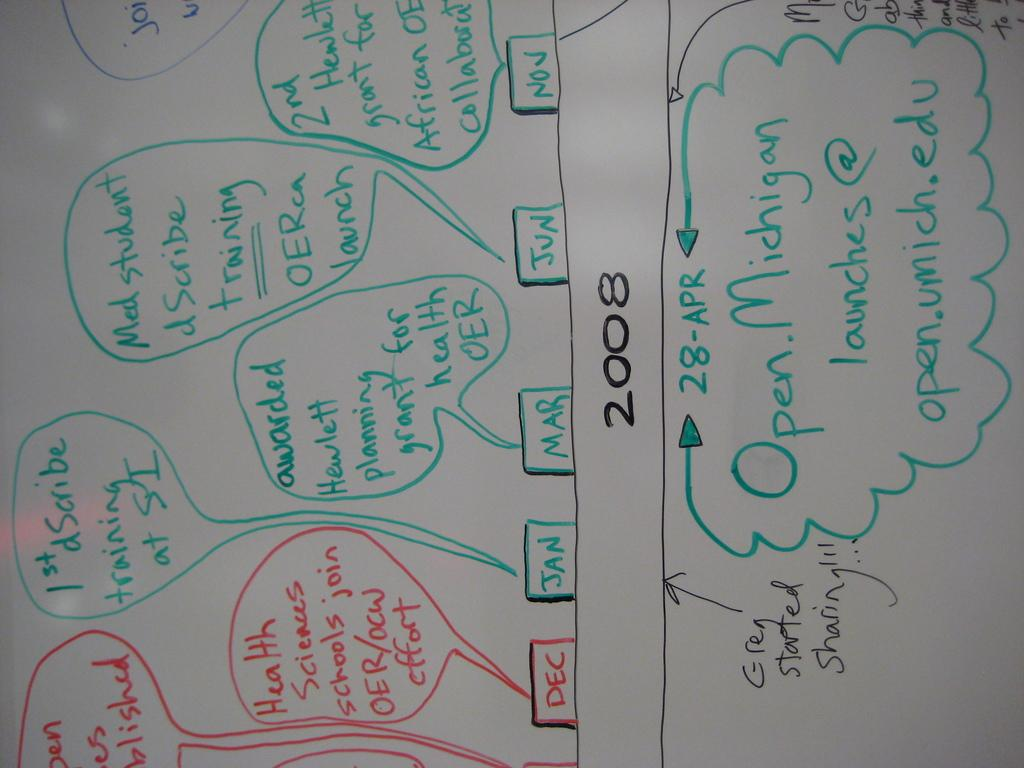<image>
Write a terse but informative summary of the picture. A timeline for the year 2008 for university health sciences staff at the University of Michigan. 